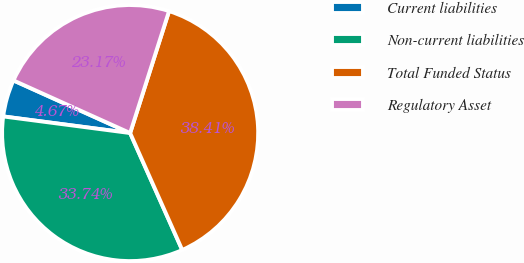Convert chart. <chart><loc_0><loc_0><loc_500><loc_500><pie_chart><fcel>Current liabilities<fcel>Non-current liabilities<fcel>Total Funded Status<fcel>Regulatory Asset<nl><fcel>4.67%<fcel>33.74%<fcel>38.41%<fcel>23.17%<nl></chart> 